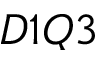Convert formula to latex. <formula><loc_0><loc_0><loc_500><loc_500>D 1 Q 3</formula> 